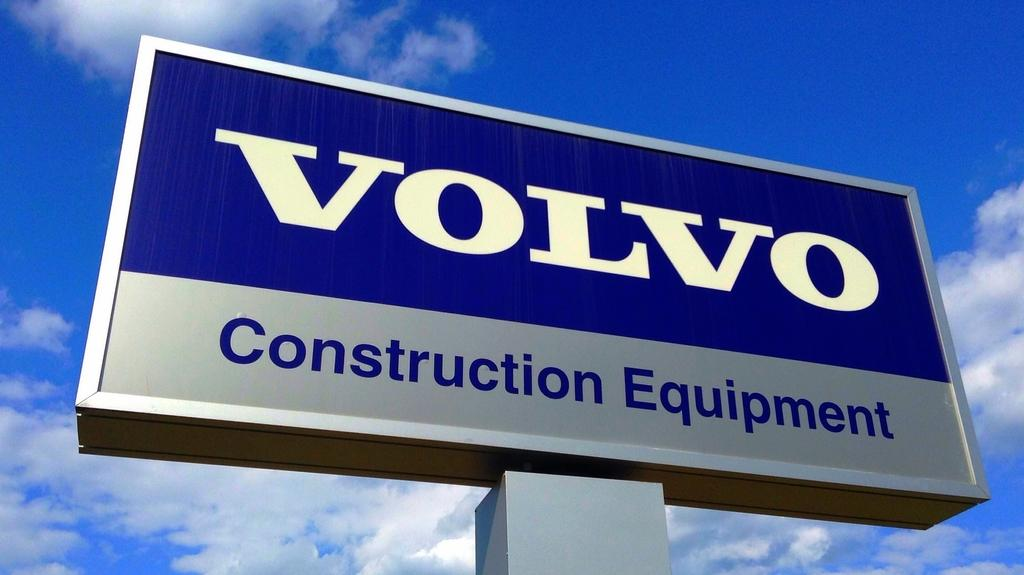Provide a one-sentence caption for the provided image. a sign reading volvo construction equipment in front of a blue sky. 